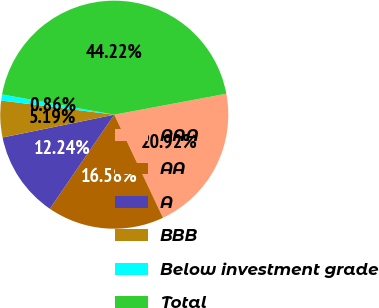Convert chart. <chart><loc_0><loc_0><loc_500><loc_500><pie_chart><fcel>AAA<fcel>AA<fcel>A<fcel>BBB<fcel>Below investment grade<fcel>Total<nl><fcel>20.92%<fcel>16.58%<fcel>12.24%<fcel>5.19%<fcel>0.86%<fcel>44.22%<nl></chart> 